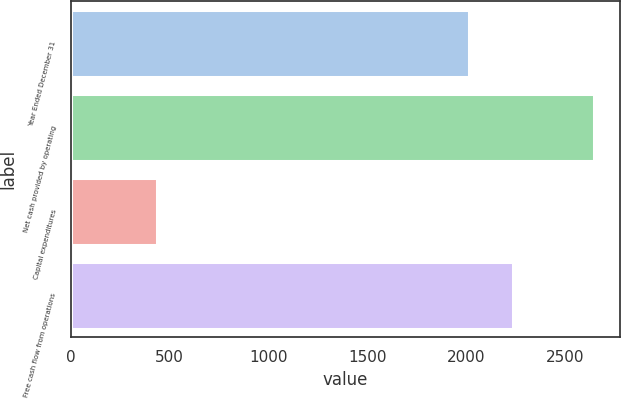Convert chart to OTSL. <chart><loc_0><loc_0><loc_500><loc_500><bar_chart><fcel>Year Ended December 31<fcel>Net cash provided by operating<fcel>Capital expenditures<fcel>Free cash flow from operations<nl><fcel>2012<fcel>2645<fcel>436<fcel>2232.9<nl></chart> 